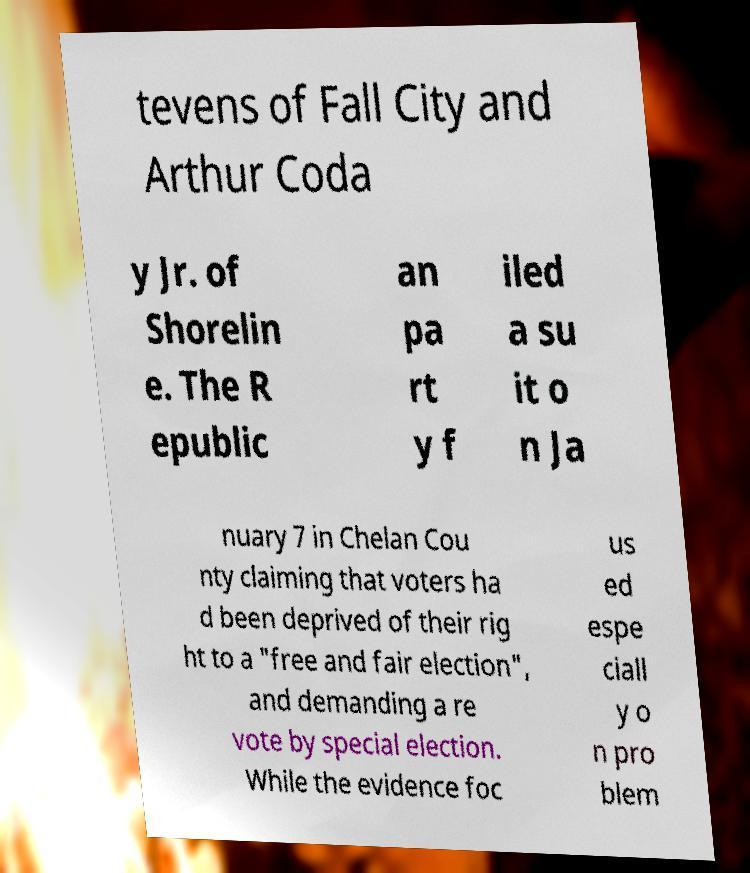Could you assist in decoding the text presented in this image and type it out clearly? tevens of Fall City and Arthur Coda y Jr. of Shorelin e. The R epublic an pa rt y f iled a su it o n Ja nuary 7 in Chelan Cou nty claiming that voters ha d been deprived of their rig ht to a "free and fair election", and demanding a re vote by special election. While the evidence foc us ed espe ciall y o n pro blem 